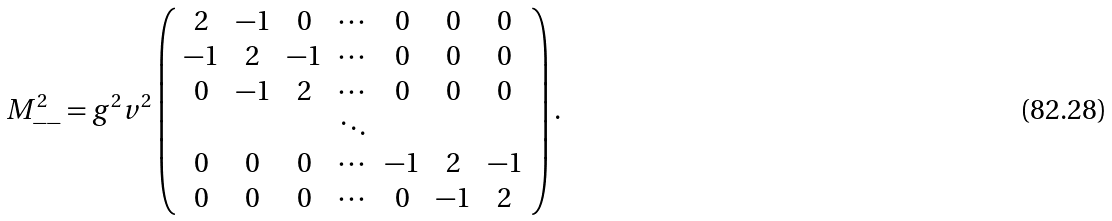<formula> <loc_0><loc_0><loc_500><loc_500>M _ { - - } ^ { 2 } = g ^ { 2 } v ^ { 2 } \left ( \begin{array} { c c c c c c c } 2 & - 1 & 0 & \cdots & 0 & 0 & 0 \\ - 1 & 2 & - 1 & \cdots & 0 & 0 & 0 \\ 0 & - 1 & 2 & \cdots & 0 & 0 & 0 \\ & & & \ddots & & & \\ 0 & 0 & 0 & \cdots & - 1 & 2 & - 1 \\ 0 & 0 & 0 & \cdots & 0 & - 1 & 2 \end{array} \right ) .</formula> 